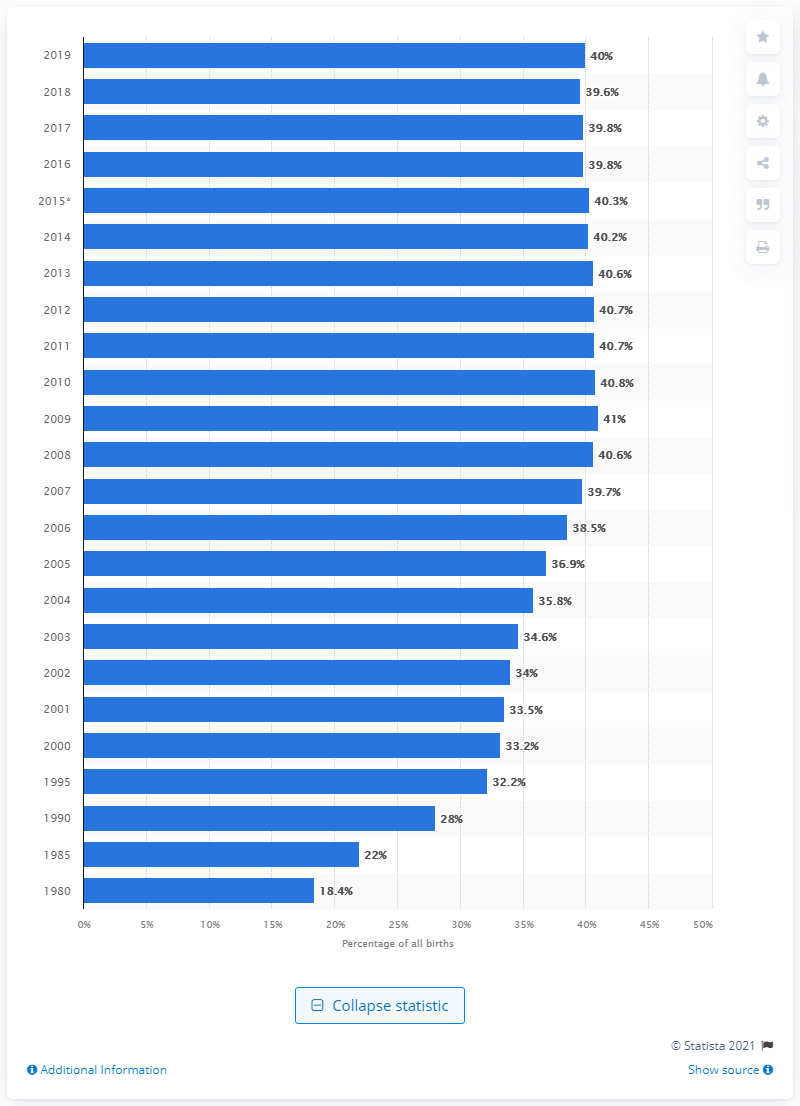Point out several critical features in this image. According to data from 2019, approximately 40% of births in the United States were unmarried. 